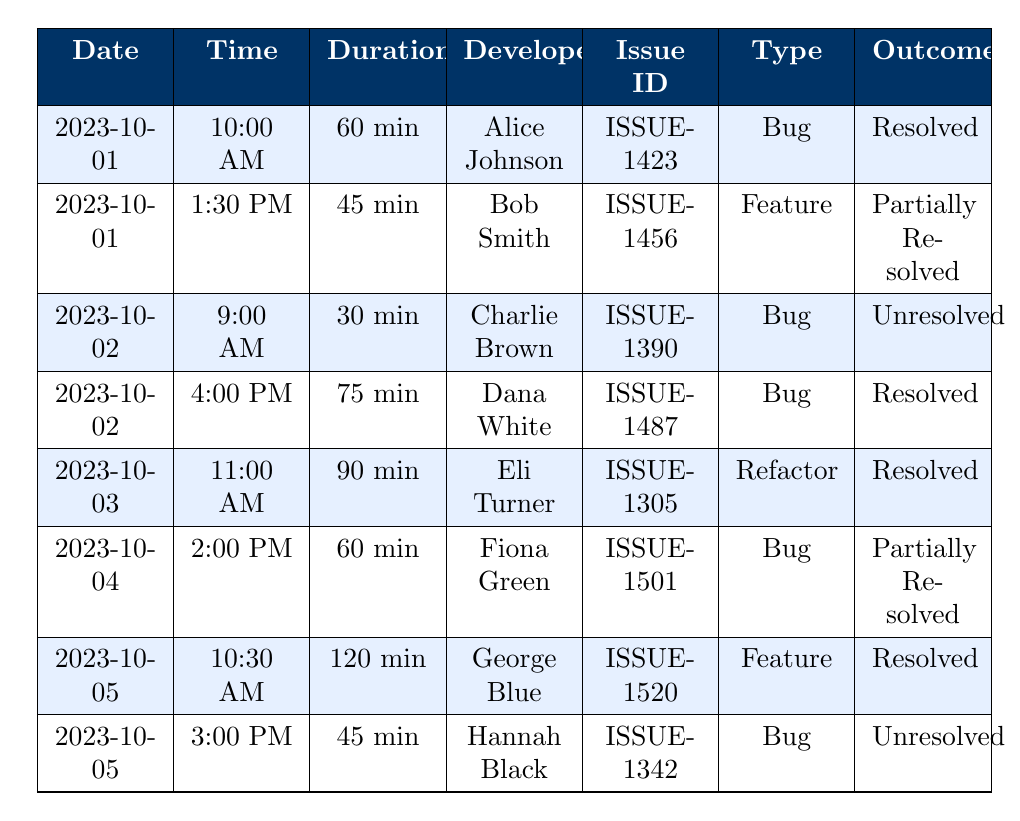What outcomes were recorded for the debugging sessions on October 1st, 2023? On October 1st, there were two sessions: the first was by Alice Johnson which resulted in "Resolved" and the second was by Bob Smith which was "Partially Resolved."
Answer: Resolved, Partially Resolved Who spent the longest time on a debugging session, and what was the outcome? George Blue had the longest session lasting 120 minutes, which resulted in "Resolved."
Answer: George Blue, Resolved How many debugging sessions were categorized as "Unresolved"? There are two sessions categorized as "Unresolved," one by Charlie Brown on October 2nd and another by Hannah Black on October 5th.
Answer: 2 What is the average duration of resolved debugging sessions? The durations of resolved sessions are 60 min (Alice), 75 min (Dana), 90 min (Eli), and 120 min (George), summing them gives 345 minutes and dividing by 4 gives an average of 86.25 minutes.
Answer: 86.25 minutes Was there a session that resulted in a "Partially Resolved" issue on October 4th? Yes, there was a session on October 4th by Fiona Green, which ended with "Partially Resolved."
Answer: Yes Which developer worked on the most issues, and how many issues did they handle? Alice Johnson worked on one issue, Bob Smith on one, Charlie Brown on one, Dana White on one, Eli Turner on one, Fiona Green on one, George Blue on one, and Hannah Black on one. All handled one issue each, so no developer worked on more than one issue.
Answer: None What was the average duration of all debugging sessions within this period? The total duration of all sessions is 60 + 45 + 30 + 75 + 90 + 60 + 120 + 45 = 525 minutes, and with 8 sessions, the average is 525/8 = 65.625 minutes.
Answer: 65.625 minutes Did any developer work on more than one debugging session? No, each developer listed in the table worked on only one session each.
Answer: No What were the types of issues that were resolved during the sessions? The resolved sessions involved the types: Bug (Alice and Dana), Refactor (Eli), and Feature (George), summing up to three types of resolved issues.
Answer: Bug, Refactor, Feature 